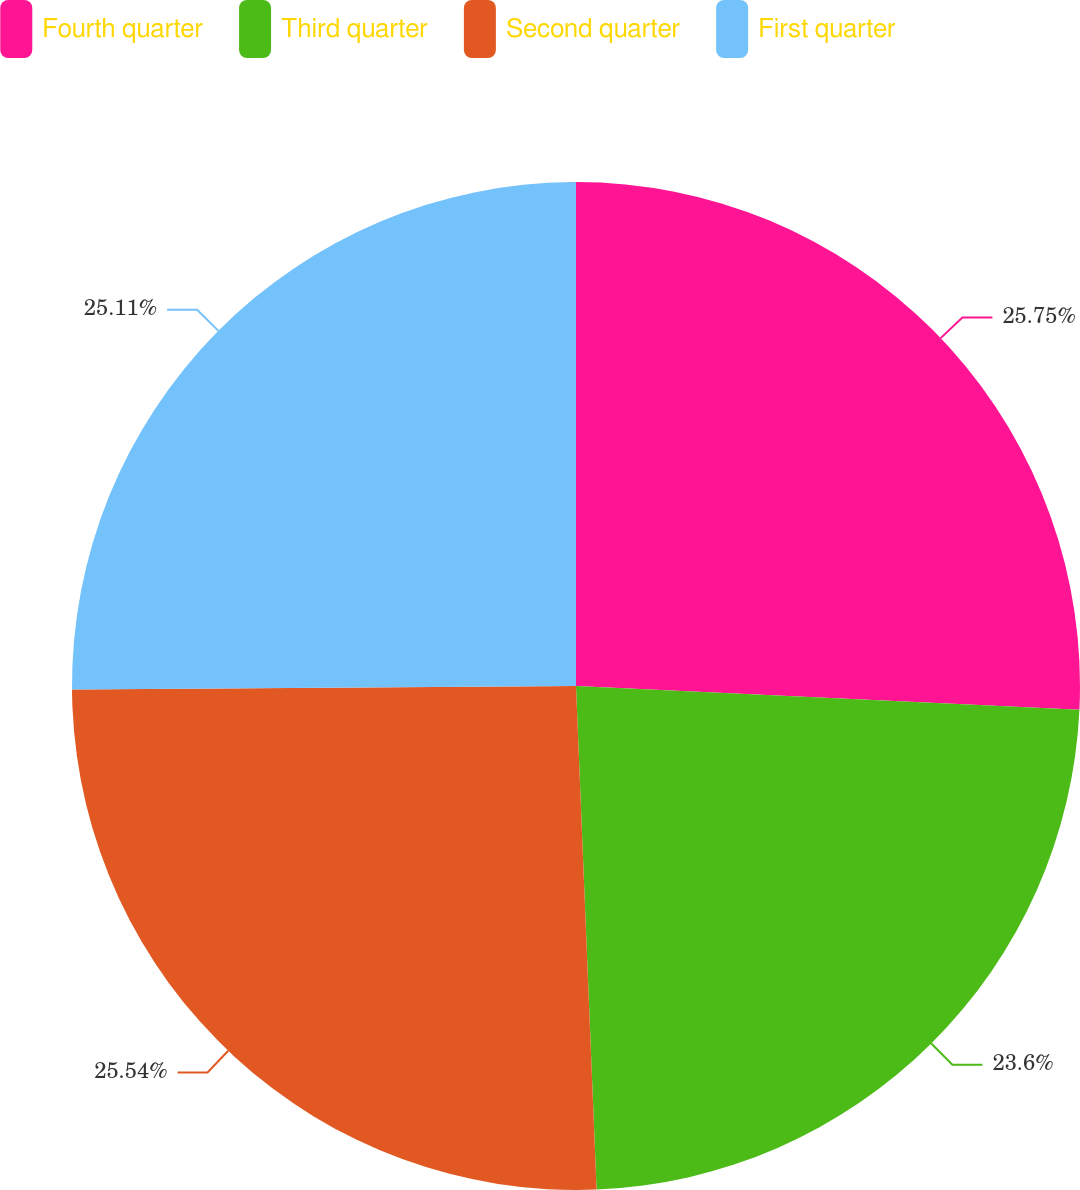<chart> <loc_0><loc_0><loc_500><loc_500><pie_chart><fcel>Fourth quarter<fcel>Third quarter<fcel>Second quarter<fcel>First quarter<nl><fcel>25.75%<fcel>23.6%<fcel>25.54%<fcel>25.11%<nl></chart> 